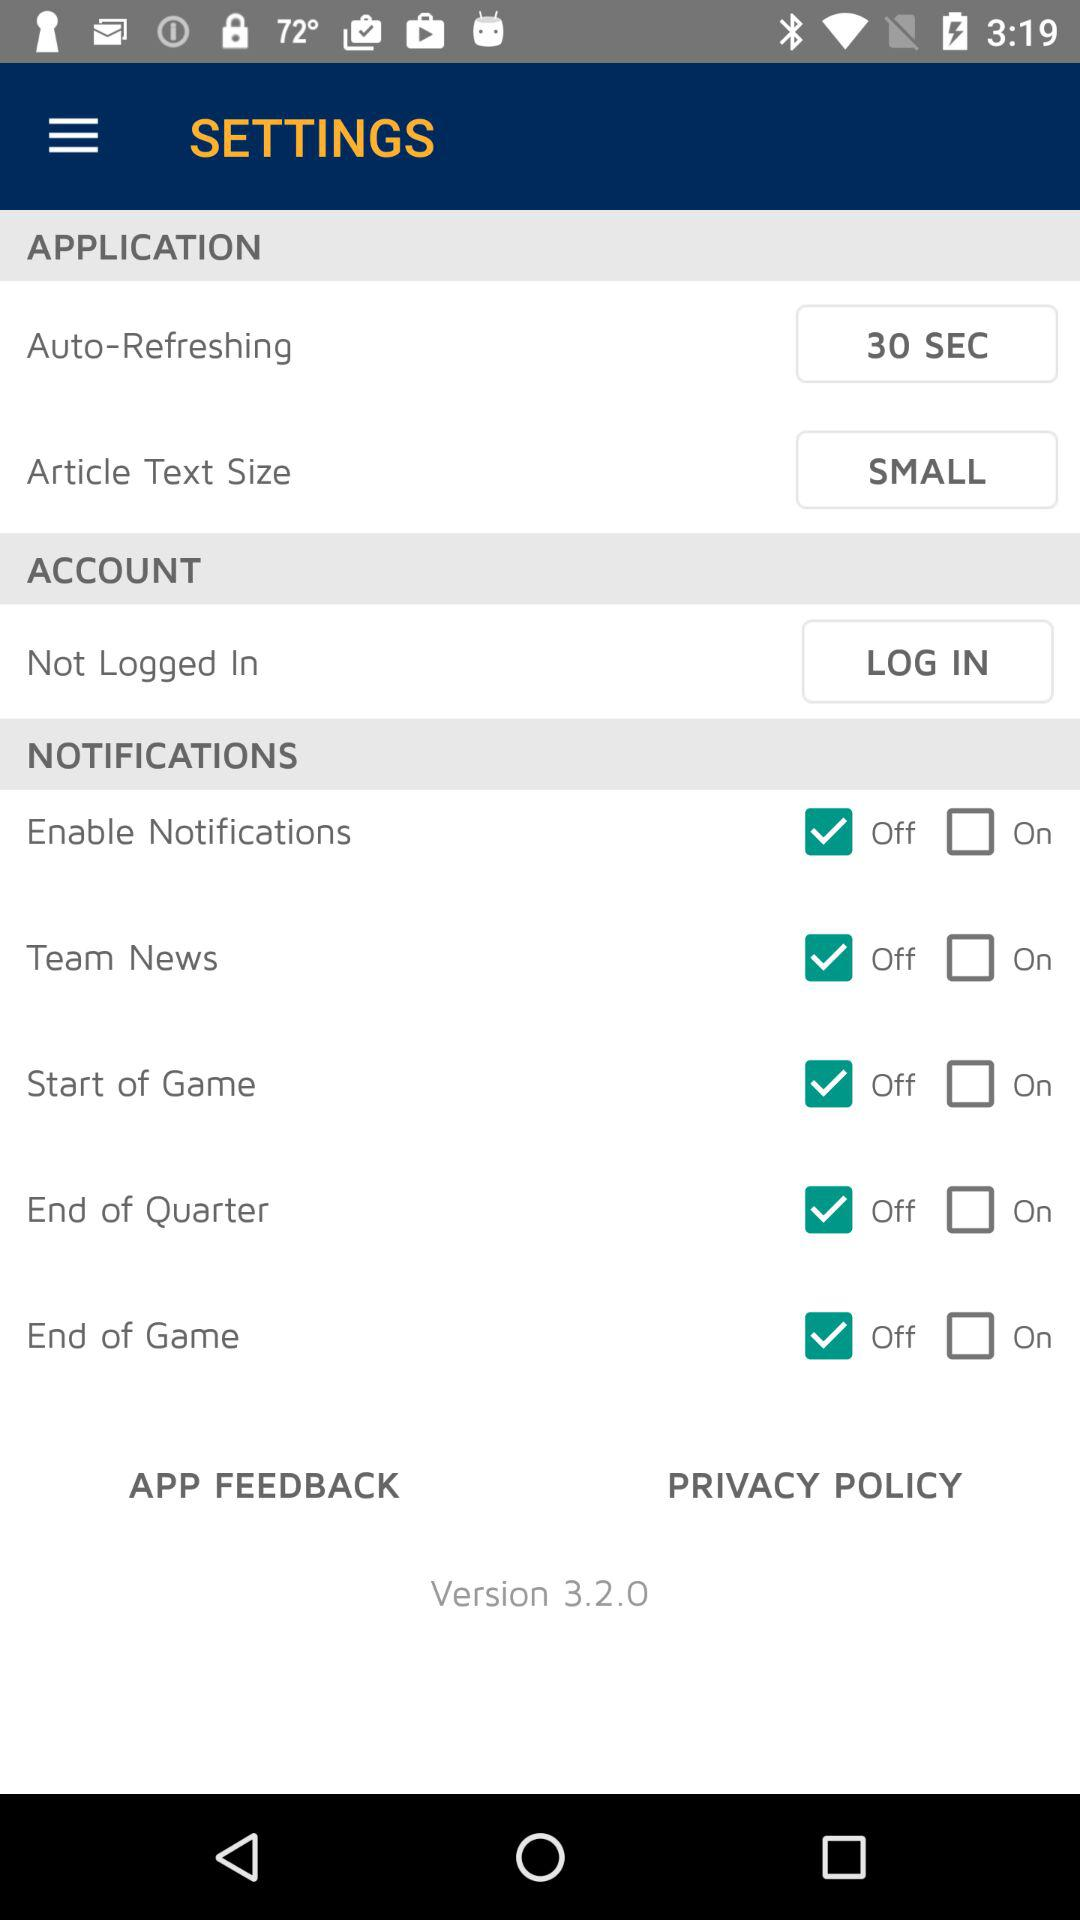What is the auto-refresh time? The auto-refresh time is 30 seconds. 